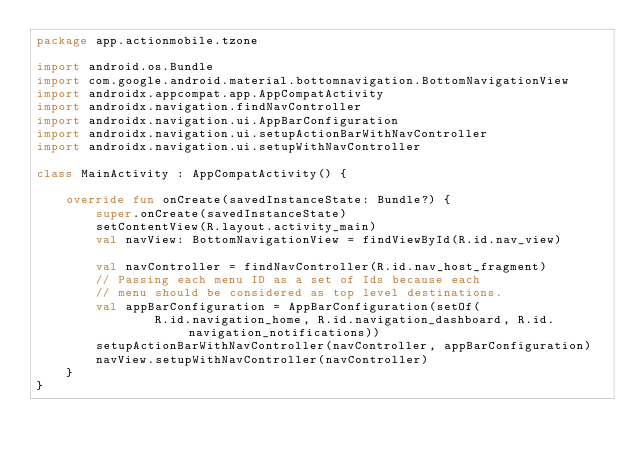<code> <loc_0><loc_0><loc_500><loc_500><_Kotlin_>package app.actionmobile.tzone

import android.os.Bundle
import com.google.android.material.bottomnavigation.BottomNavigationView
import androidx.appcompat.app.AppCompatActivity
import androidx.navigation.findNavController
import androidx.navigation.ui.AppBarConfiguration
import androidx.navigation.ui.setupActionBarWithNavController
import androidx.navigation.ui.setupWithNavController

class MainActivity : AppCompatActivity() {

    override fun onCreate(savedInstanceState: Bundle?) {
        super.onCreate(savedInstanceState)
        setContentView(R.layout.activity_main)
        val navView: BottomNavigationView = findViewById(R.id.nav_view)

        val navController = findNavController(R.id.nav_host_fragment)
        // Passing each menu ID as a set of Ids because each
        // menu should be considered as top level destinations.
        val appBarConfiguration = AppBarConfiguration(setOf(
                R.id.navigation_home, R.id.navigation_dashboard, R.id.navigation_notifications))
        setupActionBarWithNavController(navController, appBarConfiguration)
        navView.setupWithNavController(navController)
    }
}</code> 